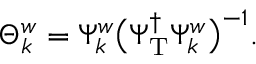Convert formula to latex. <formula><loc_0><loc_0><loc_500><loc_500>\Theta _ { k } ^ { w } = \Psi _ { k } ^ { w } \left ( \Psi _ { T } ^ { \dagger } \Psi _ { k } ^ { w } \right ) ^ { - 1 } .</formula> 